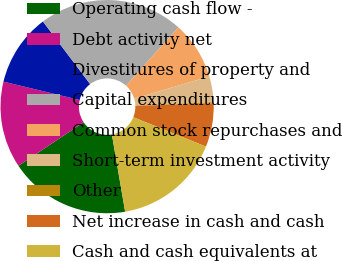Convert chart to OTSL. <chart><loc_0><loc_0><loc_500><loc_500><pie_chart><fcel>Operating cash flow -<fcel>Debt activity net<fcel>Divestitures of property and<fcel>Capital expenditures<fcel>Common stock repurchases and<fcel>Short-term investment activity<fcel>Other<fcel>Net increase in cash and cash<fcel>Cash and cash equivalents at<nl><fcel>18.35%<fcel>13.13%<fcel>10.95%<fcel>21.94%<fcel>8.77%<fcel>3.93%<fcel>0.16%<fcel>6.6%<fcel>16.18%<nl></chart> 